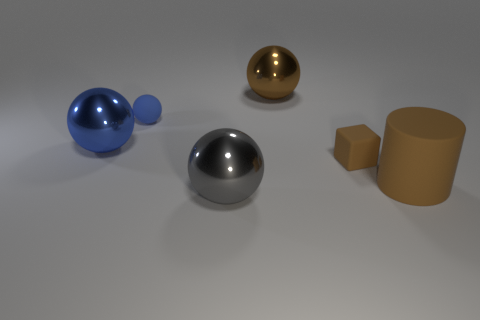Subtract all yellow cubes. How many blue spheres are left? 2 Add 3 small objects. How many objects exist? 9 Subtract all tiny balls. How many balls are left? 3 Subtract all gray spheres. How many spheres are left? 3 Subtract all gray balls. Subtract all blue cylinders. How many balls are left? 3 Subtract all large red shiny cylinders. Subtract all metal spheres. How many objects are left? 3 Add 1 large metallic spheres. How many large metallic spheres are left? 4 Add 3 brown balls. How many brown balls exist? 4 Subtract 0 purple cubes. How many objects are left? 6 Subtract all cylinders. How many objects are left? 5 